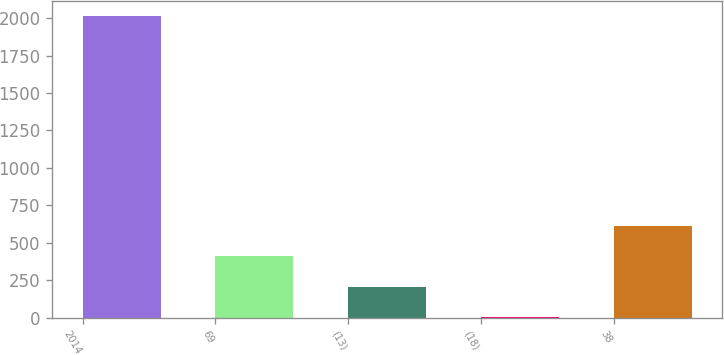Convert chart. <chart><loc_0><loc_0><loc_500><loc_500><bar_chart><fcel>2014<fcel>69<fcel>(13)<fcel>(18)<fcel>38<nl><fcel>2012<fcel>408<fcel>207.5<fcel>7<fcel>608.5<nl></chart> 